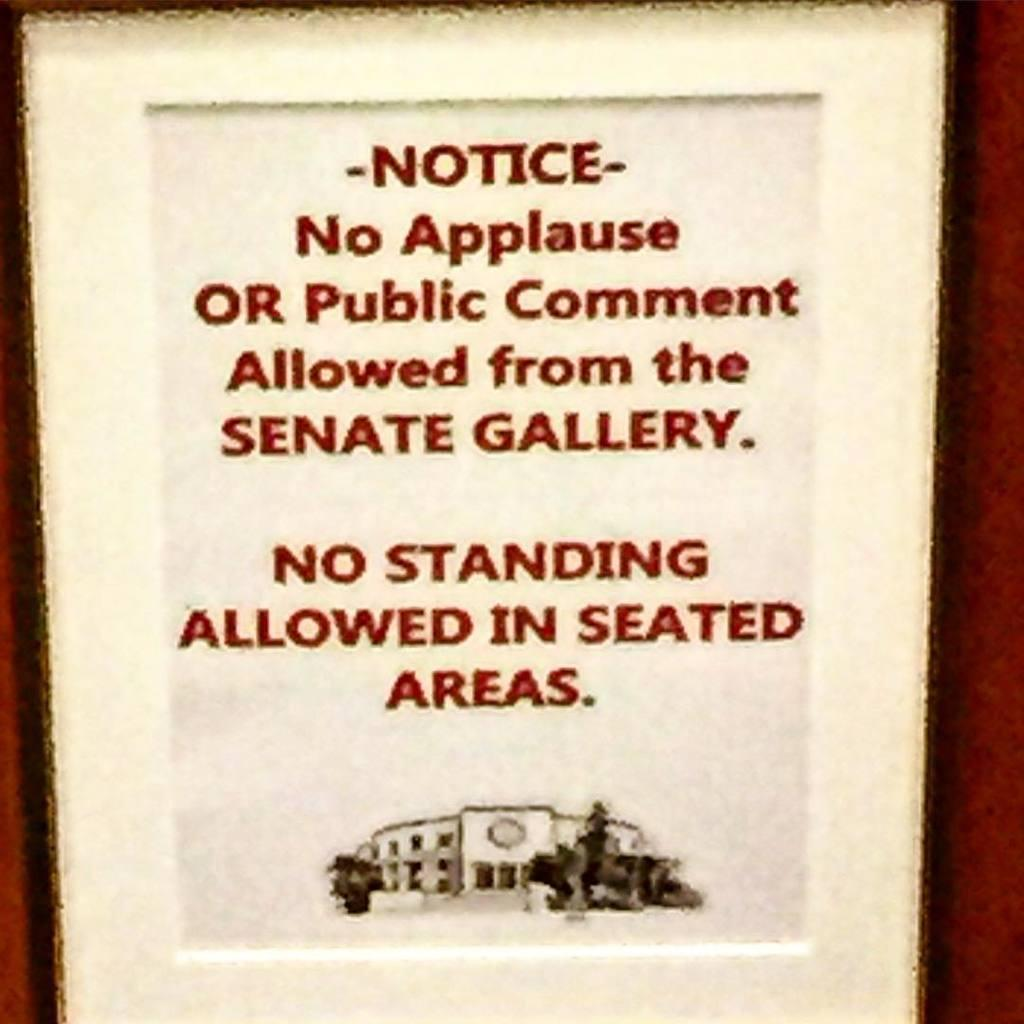<image>
Present a compact description of the photo's key features. A sign that states no standing allowed in seated areas. 